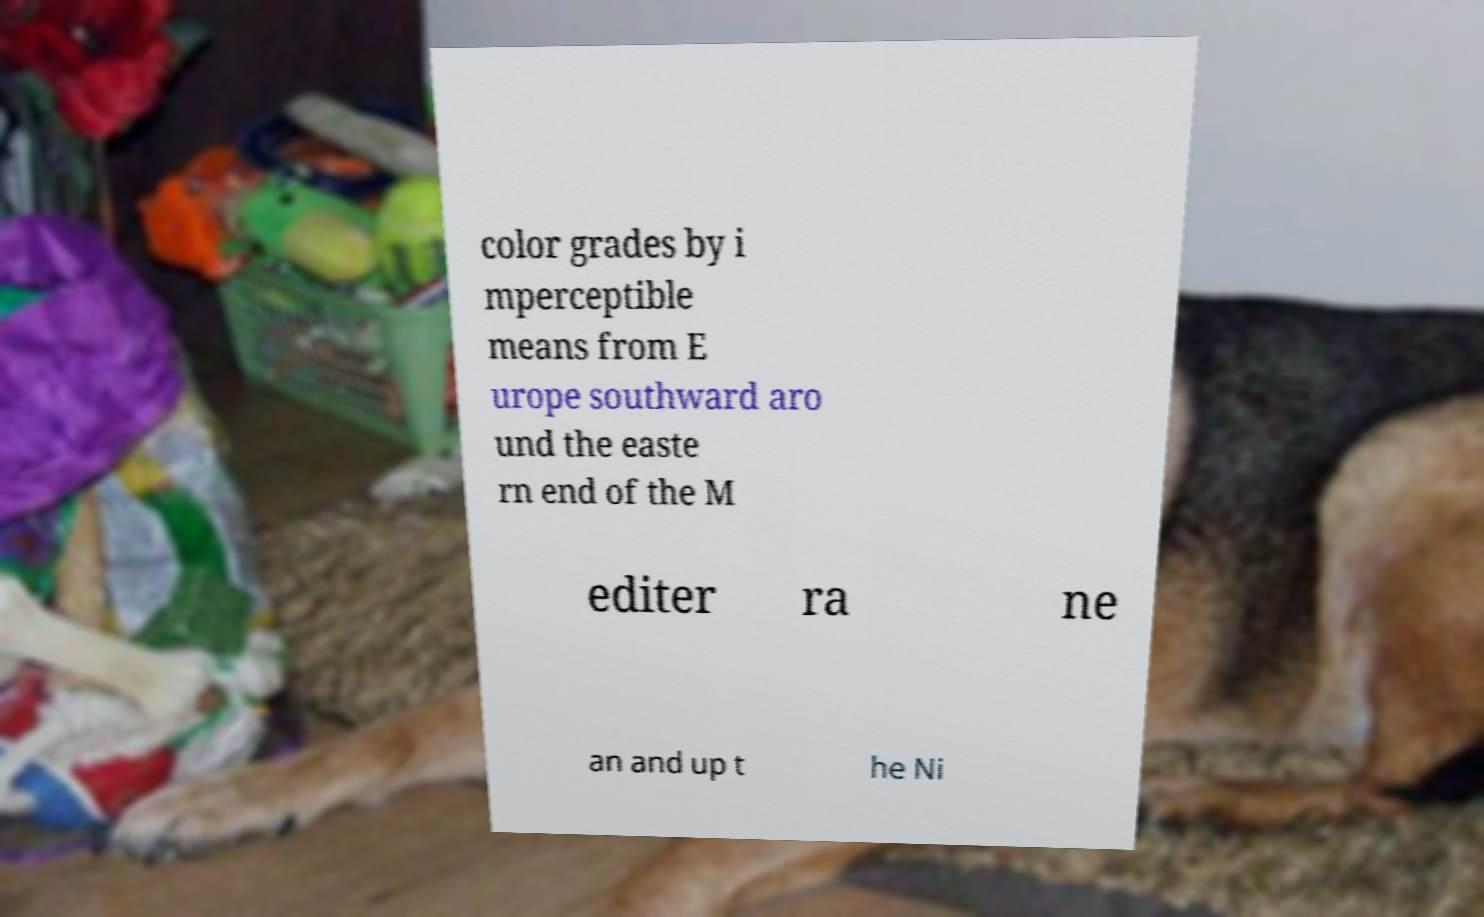I need the written content from this picture converted into text. Can you do that? color grades by i mperceptible means from E urope southward aro und the easte rn end of the M editer ra ne an and up t he Ni 